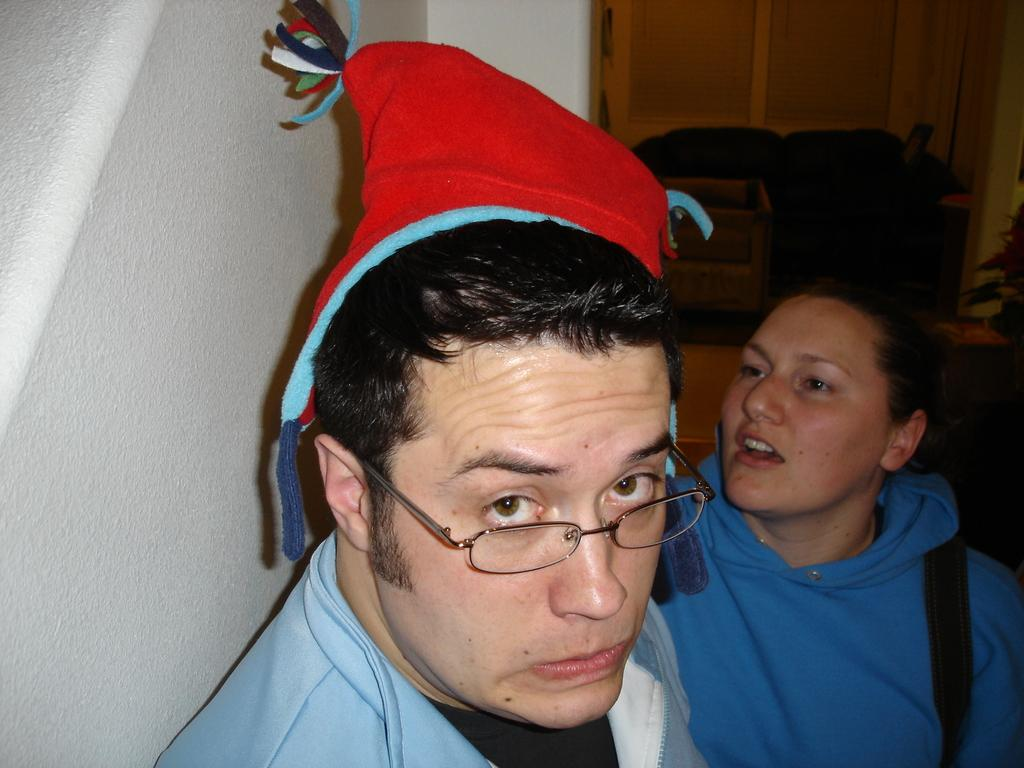How many people are present in the image? There are two people, a man and a woman, present in the image. What is the man wearing on his head? The man is wearing a cap. What type of furniture can be seen in the image? There is a couch in the image. What architectural feature is present in the image? There is a wall and a door in the image. What object can be used for storage or holding items? There is a container in the image. How many pears are on the couch in the image? There are no pears present in the image; the conversation does not mention any fruit. 